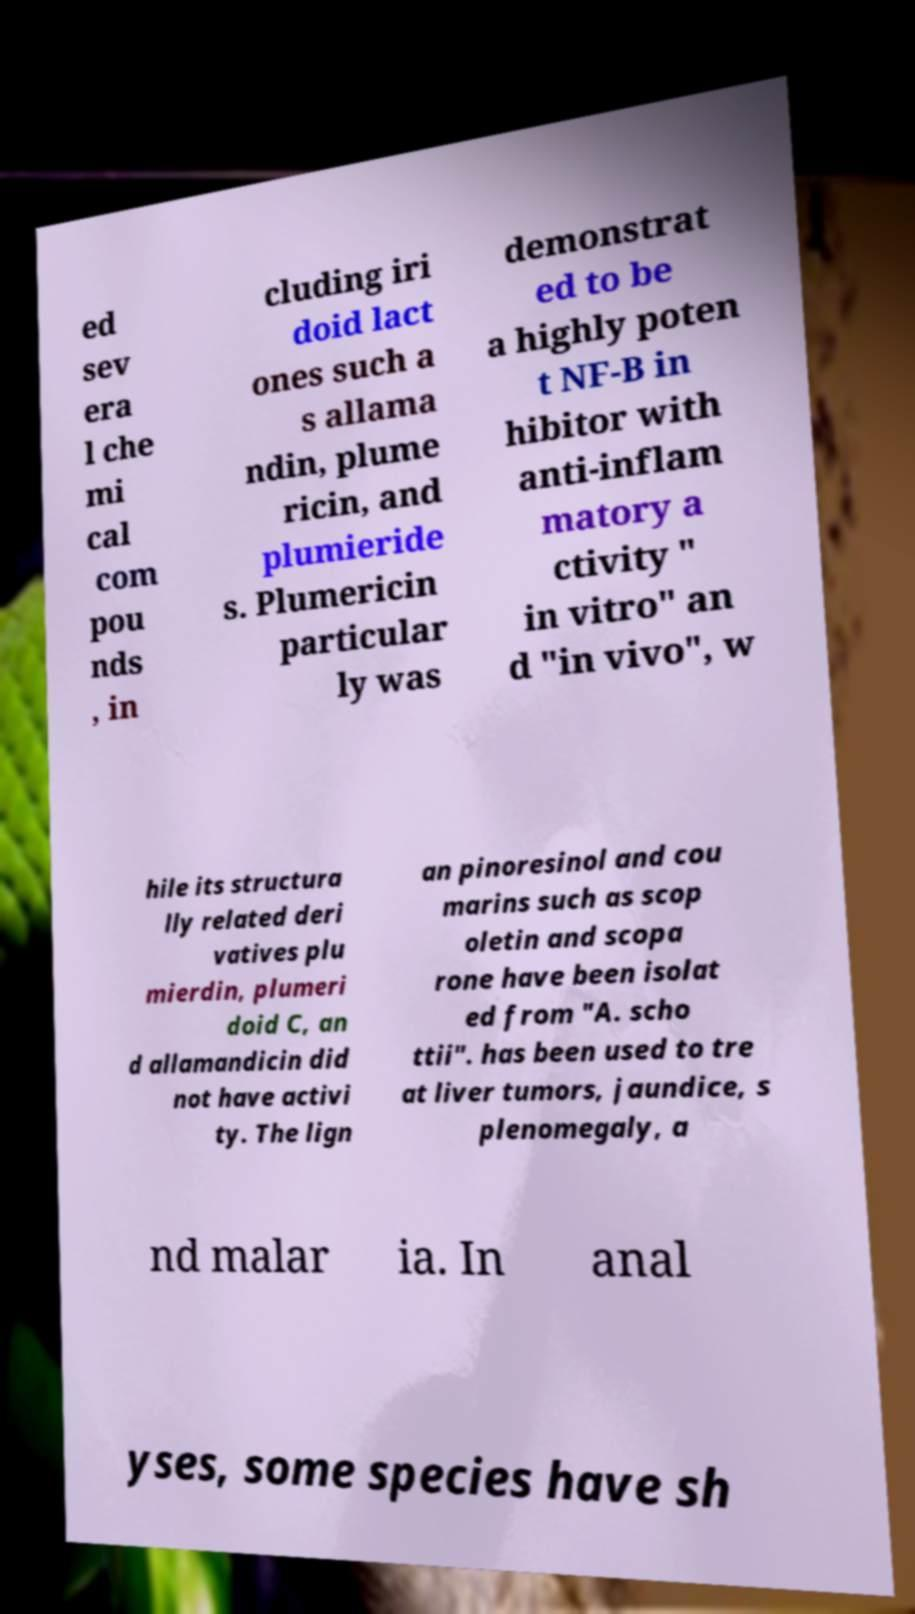Please identify and transcribe the text found in this image. ed sev era l che mi cal com pou nds , in cluding iri doid lact ones such a s allama ndin, plume ricin, and plumieride s. Plumericin particular ly was demonstrat ed to be a highly poten t NF-B in hibitor with anti-inflam matory a ctivity " in vitro" an d "in vivo", w hile its structura lly related deri vatives plu mierdin, plumeri doid C, an d allamandicin did not have activi ty. The lign an pinoresinol and cou marins such as scop oletin and scopa rone have been isolat ed from "A. scho ttii". has been used to tre at liver tumors, jaundice, s plenomegaly, a nd malar ia. In anal yses, some species have sh 